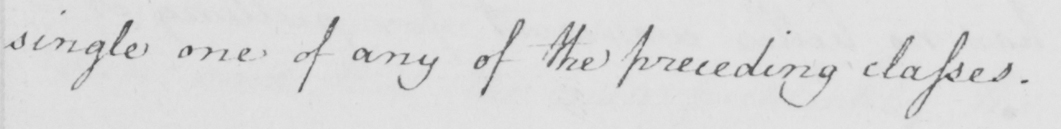What does this handwritten line say? single one of any of the preceding classes . 